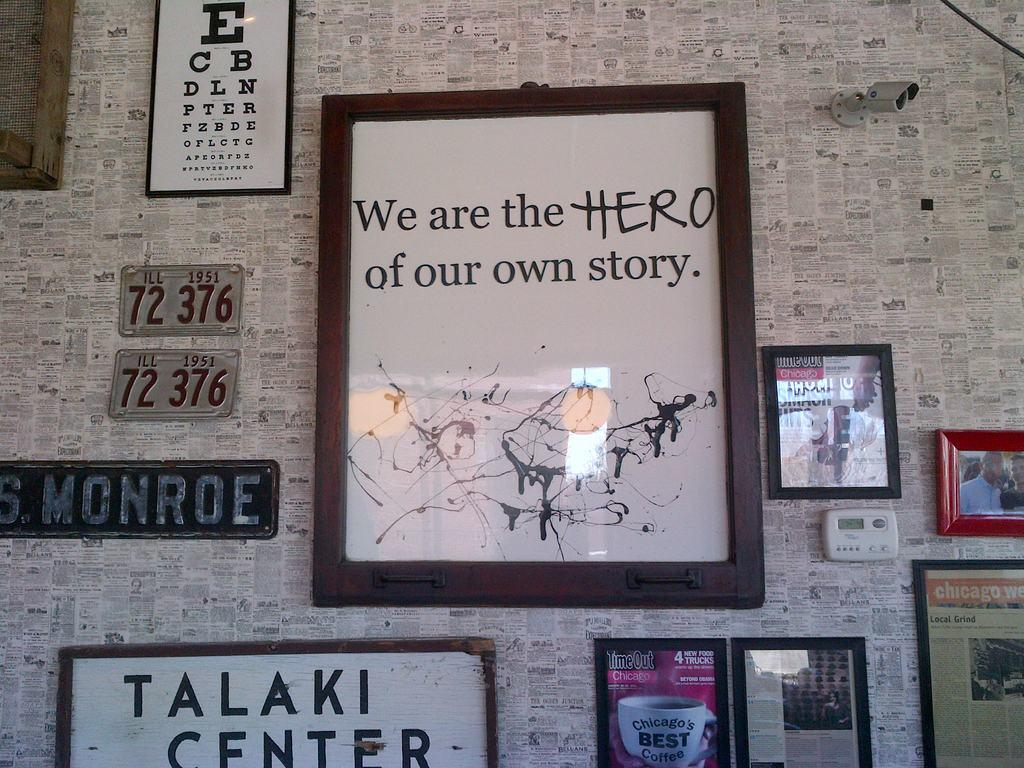<image>
Create a compact narrative representing the image presented. the word story is on the large and white poster 